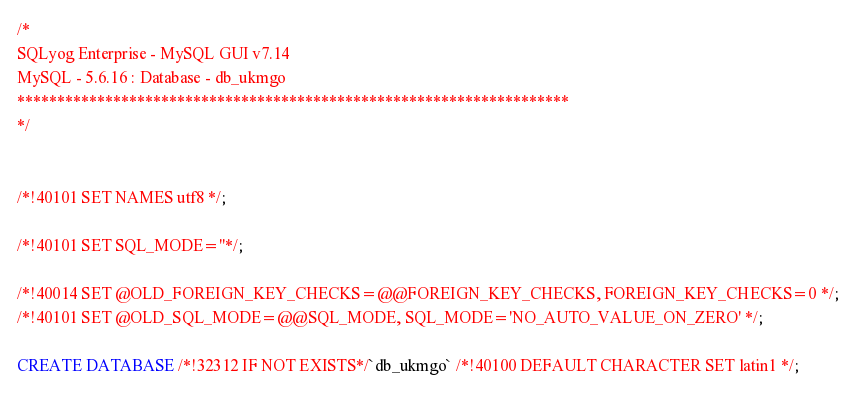Convert code to text. <code><loc_0><loc_0><loc_500><loc_500><_SQL_>/*
SQLyog Enterprise - MySQL GUI v7.14 
MySQL - 5.6.16 : Database - db_ukmgo
*********************************************************************
*/

/*!40101 SET NAMES utf8 */;

/*!40101 SET SQL_MODE=''*/;

/*!40014 SET @OLD_FOREIGN_KEY_CHECKS=@@FOREIGN_KEY_CHECKS, FOREIGN_KEY_CHECKS=0 */;
/*!40101 SET @OLD_SQL_MODE=@@SQL_MODE, SQL_MODE='NO_AUTO_VALUE_ON_ZERO' */;

CREATE DATABASE /*!32312 IF NOT EXISTS*/`db_ukmgo` /*!40100 DEFAULT CHARACTER SET latin1 */;
</code> 